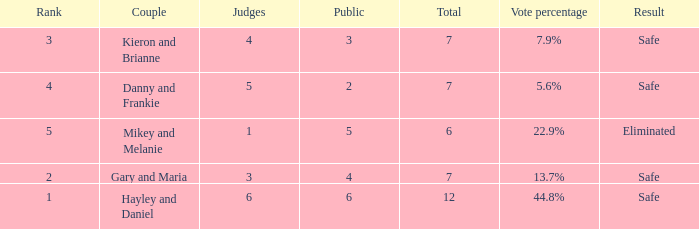What is the number of public that was there when the vote percentage was 22.9%? 1.0. 